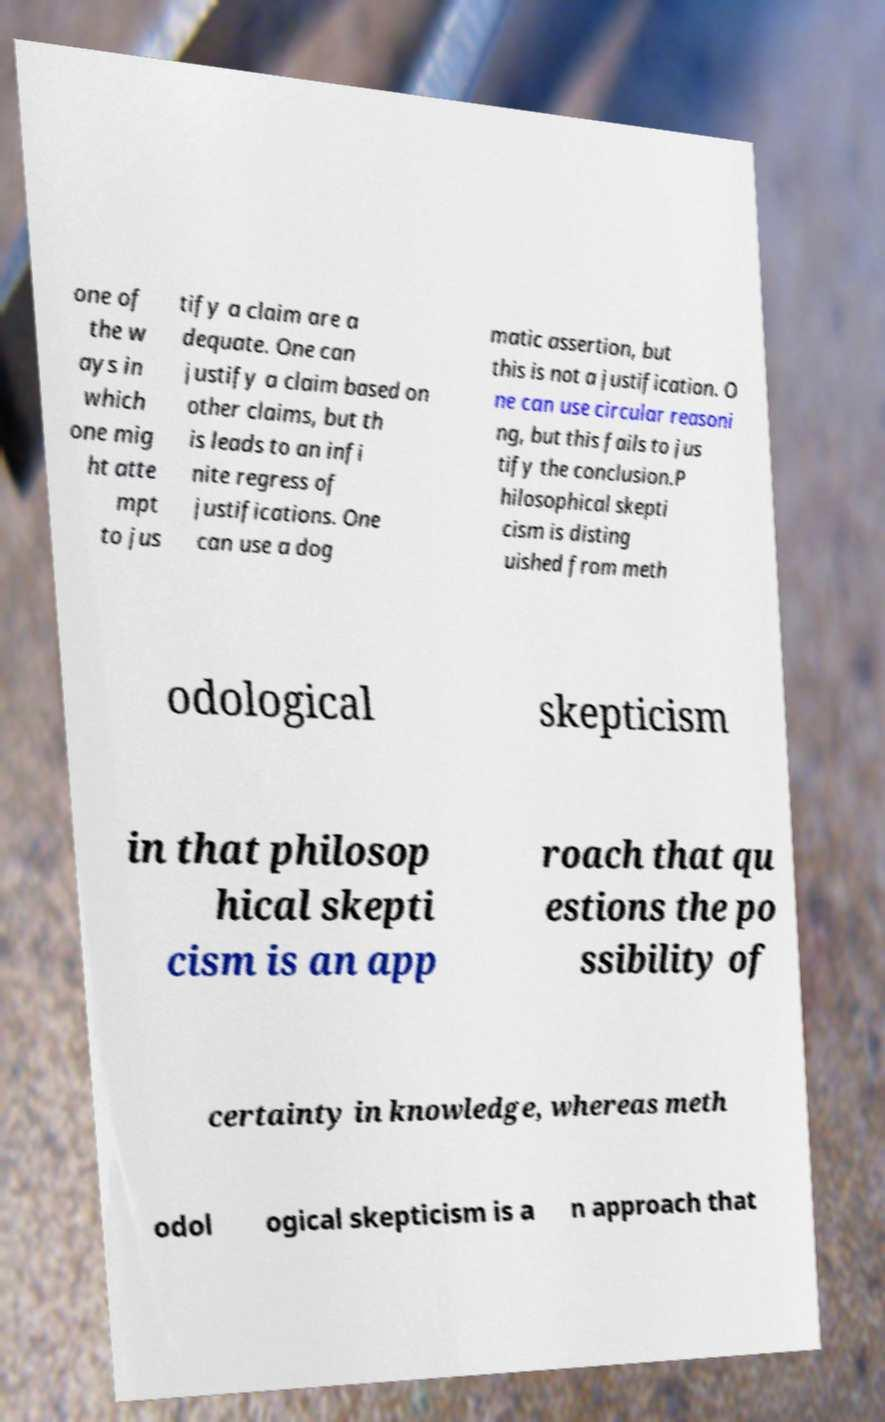Can you accurately transcribe the text from the provided image for me? one of the w ays in which one mig ht atte mpt to jus tify a claim are a dequate. One can justify a claim based on other claims, but th is leads to an infi nite regress of justifications. One can use a dog matic assertion, but this is not a justification. O ne can use circular reasoni ng, but this fails to jus tify the conclusion.P hilosophical skepti cism is disting uished from meth odological skepticism in that philosop hical skepti cism is an app roach that qu estions the po ssibility of certainty in knowledge, whereas meth odol ogical skepticism is a n approach that 